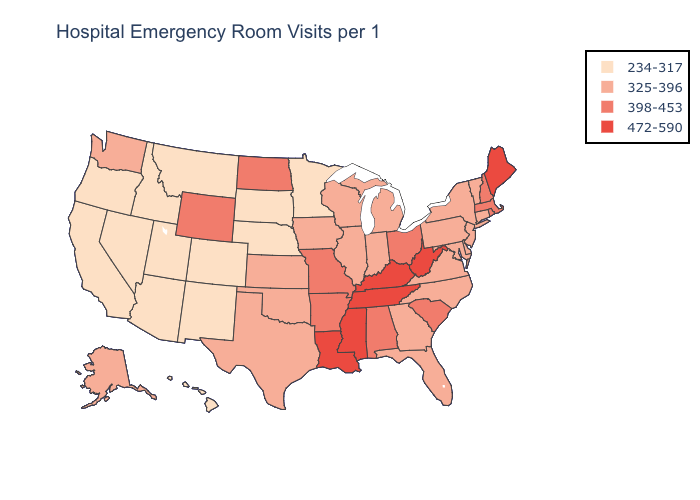Among the states that border North Dakota , which have the highest value?
Be succinct. Minnesota, Montana, South Dakota. What is the lowest value in the West?
Concise answer only. 234-317. Does the first symbol in the legend represent the smallest category?
Quick response, please. Yes. What is the highest value in states that border Illinois?
Concise answer only. 472-590. Name the states that have a value in the range 325-396?
Give a very brief answer. Alaska, Connecticut, Delaware, Florida, Georgia, Illinois, Indiana, Iowa, Kansas, Maryland, Michigan, New Jersey, New York, North Carolina, Oklahoma, Pennsylvania, Texas, Vermont, Virginia, Washington, Wisconsin. What is the value of New York?
Keep it brief. 325-396. Does the map have missing data?
Quick response, please. No. What is the highest value in states that border New Hampshire?
Answer briefly. 472-590. How many symbols are there in the legend?
Be succinct. 4. What is the lowest value in the USA?
Answer briefly. 234-317. What is the value of Maine?
Short answer required. 472-590. What is the value of New Jersey?
Concise answer only. 325-396. Is the legend a continuous bar?
Be succinct. No. Does Florida have a lower value than California?
Be succinct. No. Does Vermont have the lowest value in the USA?
Keep it brief. No. 